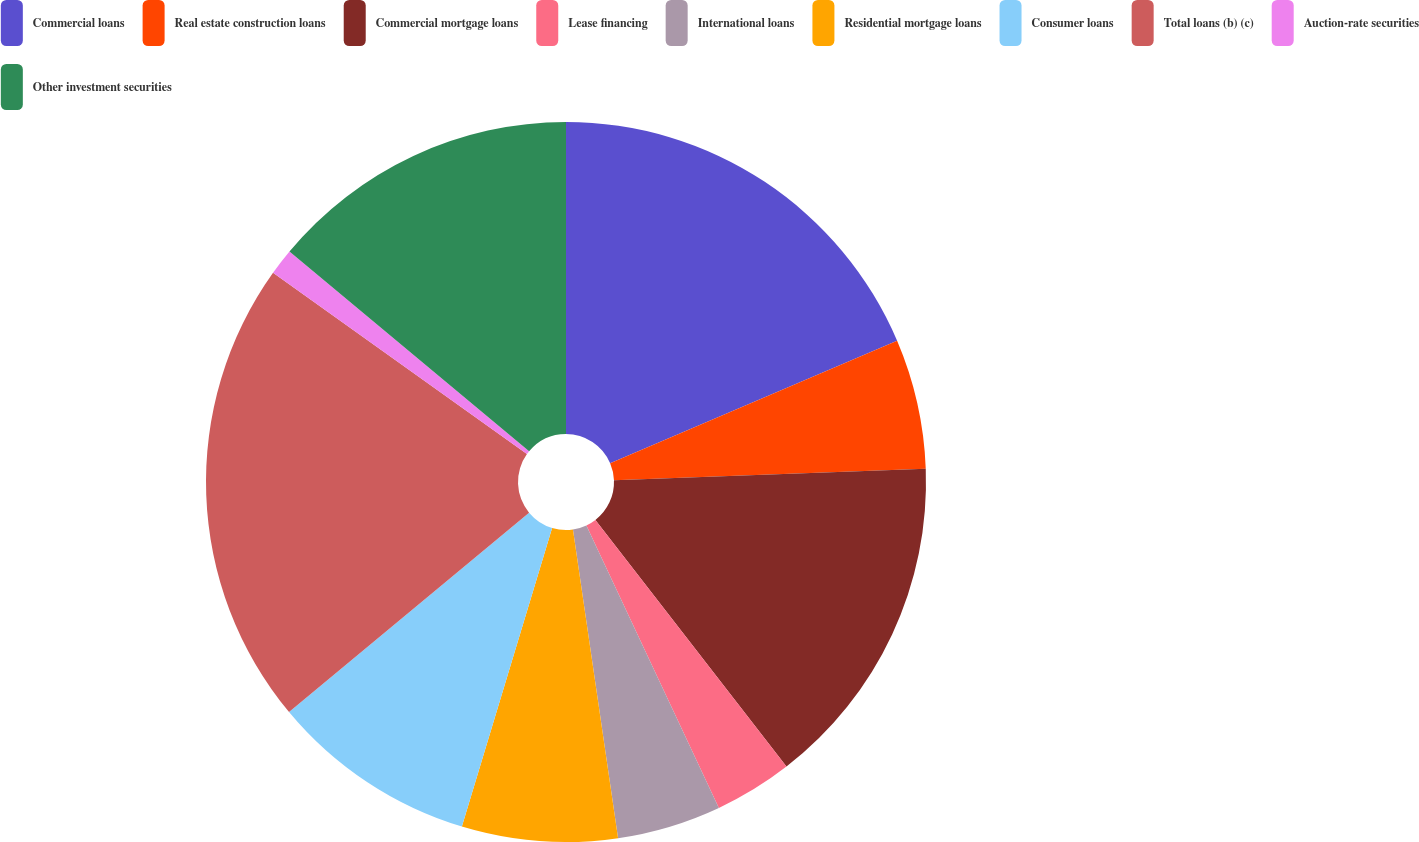<chart> <loc_0><loc_0><loc_500><loc_500><pie_chart><fcel>Commercial loans<fcel>Real estate construction loans<fcel>Commercial mortgage loans<fcel>Lease financing<fcel>International loans<fcel>Residential mortgage loans<fcel>Consumer loans<fcel>Total loans (b) (c)<fcel>Auction-rate securities<fcel>Other investment securities<nl><fcel>18.58%<fcel>5.83%<fcel>15.1%<fcel>3.51%<fcel>4.67%<fcel>6.98%<fcel>9.3%<fcel>20.9%<fcel>1.19%<fcel>13.94%<nl></chart> 